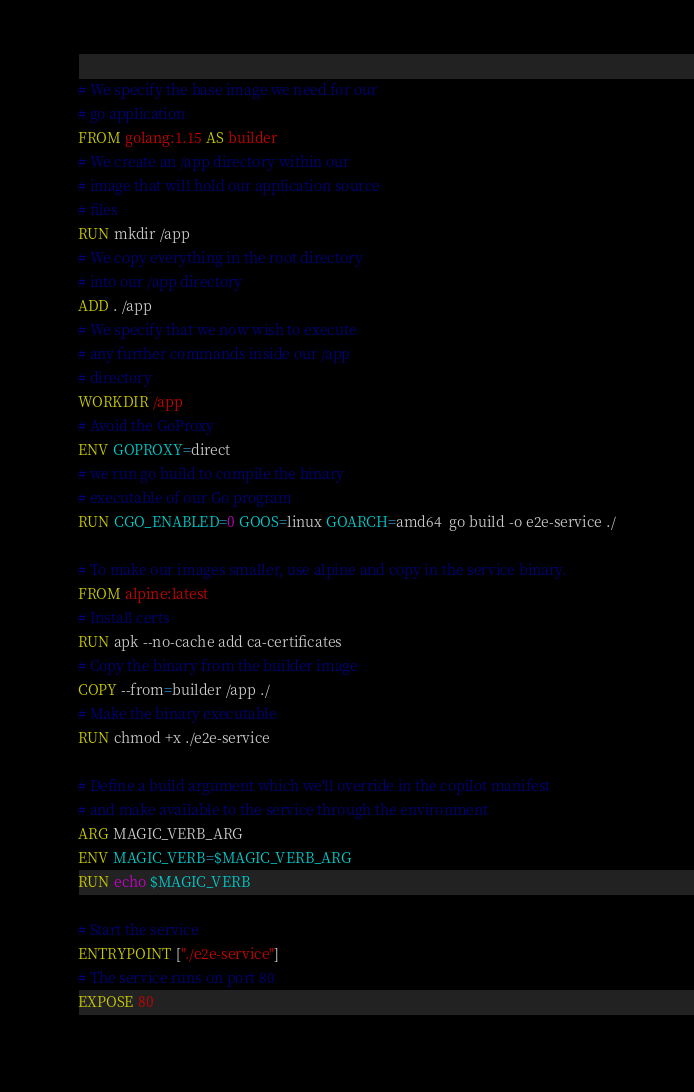Convert code to text. <code><loc_0><loc_0><loc_500><loc_500><_Dockerfile_># We specify the base image we need for our
# go application
FROM golang:1.15 AS builder
# We create an /app directory within our
# image that will hold our application source
# files
RUN mkdir /app
# We copy everything in the root directory
# into our /app directory
ADD . /app
# We specify that we now wish to execute
# any further commands inside our /app
# directory
WORKDIR /app
# Avoid the GoProxy
ENV GOPROXY=direct
# we run go build to compile the binary
# executable of our Go program
RUN CGO_ENABLED=0 GOOS=linux GOARCH=amd64  go build -o e2e-service ./

# To make our images smaller, use alpine and copy in the service binary.
FROM alpine:latest
# Install certs
RUN apk --no-cache add ca-certificates
# Copy the binary from the builder image
COPY --from=builder /app ./
# Make the binary executable
RUN chmod +x ./e2e-service

# Define a build argument which we'll override in the copilot manifest
# and make available to the service through the environment
ARG MAGIC_VERB_ARG
ENV MAGIC_VERB=$MAGIC_VERB_ARG
RUN echo $MAGIC_VERB

# Start the service
ENTRYPOINT ["./e2e-service"]
# The service runs on port 80
EXPOSE 80
</code> 